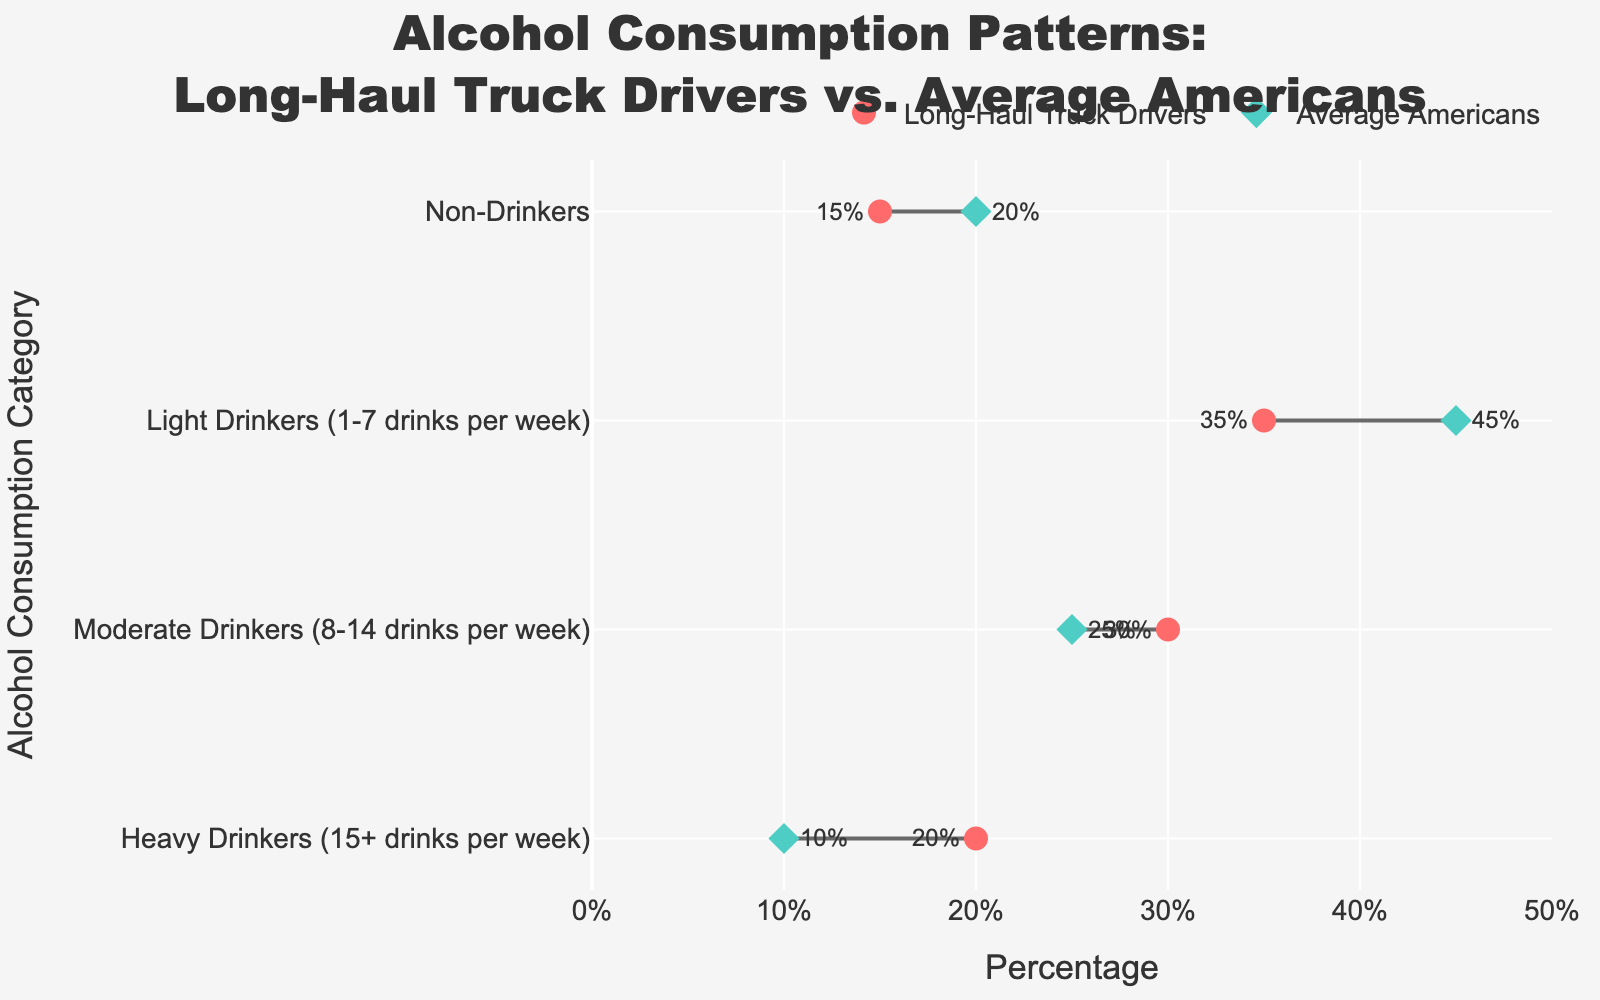Which group has a higher percentage of non-drinkers, Long-Haul Truck Drivers or Average Americans? To determine which group has a higher percentage of non-drinkers, look at the two data points for "Non-Drinkers" in the figure. Long-Haul Truck Drivers have 15%, while Average Americans have 20%.
Answer: Average Americans What is the percentage difference in heavy drinkers between Long-Haul Truck Drivers and Average Americans? To find the percentage difference in heavy drinkers, subtract the percentage of heavy drinkers among Average Americans from the percentage among Long-Haul Truck Drivers. That is 20% - 10% = 10%.
Answer: 10% How do light drinkers compare between Long-Haul Truck Drivers and Average Americans? Look at the data points for "Light Drinkers (1-7 drinks per week)" in the figure. Long-Haul Truck Drivers have 35% light drinkers, while Average Americans have 45%. Therefore, Average Americans have a higher percentage than Long-Haul Truck Drivers.
Answer: Average Americans have a higher percentage Which group has a higher proportion of moderate drinkers? To determine which group has a higher proportion of moderate drinkers, check the data points for "Moderate Drinkers (8-14 drinks per week)". Long-Haul Truck Drivers have 30%, while Average Americans have 25%. Thus, Long-Haul Truck Drivers have a higher proportion.
Answer: Long-Haul Truck Drivers What is the sum of percentages for non-drinkers and heavy drinkers among Long-Haul Truck Drivers? To find the sum, add the percentages for non-drinkers and heavy drinkers among Long-Haul Truck Drivers, which are 15% and 20%, respectively. 15% + 20% = 35%.
Answer: 35% What is the total percentage of all drinking categories (excluding non-drinkers) for Average Americans? To calculate, add the percentages for light drinkers (45%), moderate drinkers (25%), and heavy drinkers (10%) among Average Americans. 45% + 25% + 10% = 80%.
Answer: 80% Which category shows the biggest gap in percentage between Long-Haul Truck Drivers and Average Americans? Compare the absolute differences between both groups for each category: for non-drinkers (20% - 15% = 5%), light drinkers (45% - 35% = 10%), moderate drinkers (30% - 25% = 5%), and heavy drinkers (20% - 10% = 10%). The biggest gaps are in light drinkers and heavy drinkers, both with a 10% difference.
Answer: Light Drinkers and Heavy Drinkers What is the average percentage of moderate drinkers across both groups? To find the average, add the percentages for moderate drinkers from both groups and divide by 2. That is (30% + 25%) / 2 = 27.5%.
Answer: 27.5% Between Long-Haul Truck Drivers and Average Americans, which group has a lower percentage of light drinkers? Look at the data points for "Light Drinkers (1-7 drinks per week)" in the figure. Long-Haul Truck Drivers have 35%, and Average Americans have 45%. Therefore, Long-Haul Truck Drivers have a lower percentage.
Answer: Long-Haul Truck Drivers 